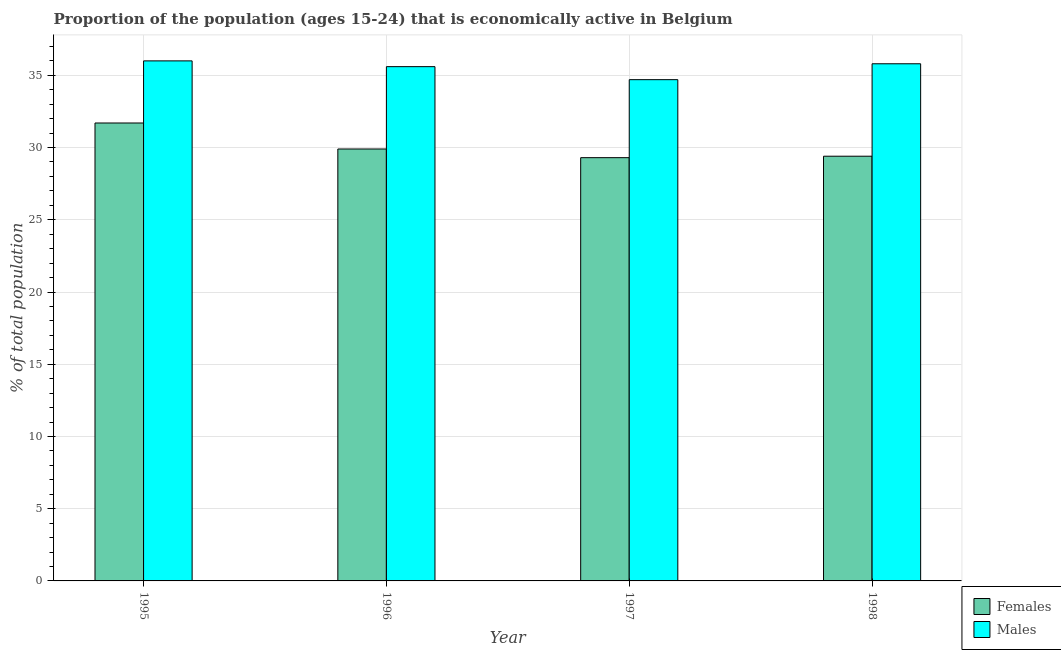How many different coloured bars are there?
Ensure brevity in your answer.  2. How many groups of bars are there?
Your answer should be very brief. 4. Are the number of bars on each tick of the X-axis equal?
Make the answer very short. Yes. How many bars are there on the 4th tick from the left?
Your answer should be very brief. 2. How many bars are there on the 4th tick from the right?
Ensure brevity in your answer.  2. What is the label of the 4th group of bars from the left?
Keep it short and to the point. 1998. What is the percentage of economically active female population in 1995?
Your response must be concise. 31.7. Across all years, what is the maximum percentage of economically active female population?
Provide a succinct answer. 31.7. Across all years, what is the minimum percentage of economically active female population?
Ensure brevity in your answer.  29.3. In which year was the percentage of economically active female population maximum?
Provide a succinct answer. 1995. What is the total percentage of economically active male population in the graph?
Offer a very short reply. 142.1. What is the difference between the percentage of economically active male population in 1995 and that in 1996?
Ensure brevity in your answer.  0.4. What is the difference between the percentage of economically active female population in 1998 and the percentage of economically active male population in 1996?
Give a very brief answer. -0.5. What is the average percentage of economically active male population per year?
Offer a very short reply. 35.52. What is the ratio of the percentage of economically active male population in 1995 to that in 1998?
Your answer should be compact. 1.01. What is the difference between the highest and the second highest percentage of economically active male population?
Keep it short and to the point. 0.2. What is the difference between the highest and the lowest percentage of economically active female population?
Ensure brevity in your answer.  2.4. In how many years, is the percentage of economically active male population greater than the average percentage of economically active male population taken over all years?
Provide a short and direct response. 3. What does the 1st bar from the left in 1998 represents?
Your response must be concise. Females. What does the 1st bar from the right in 1997 represents?
Ensure brevity in your answer.  Males. Are all the bars in the graph horizontal?
Ensure brevity in your answer.  No. How many years are there in the graph?
Your response must be concise. 4. What is the difference between two consecutive major ticks on the Y-axis?
Your answer should be very brief. 5. Are the values on the major ticks of Y-axis written in scientific E-notation?
Give a very brief answer. No. Does the graph contain any zero values?
Make the answer very short. No. Does the graph contain grids?
Your response must be concise. Yes. Where does the legend appear in the graph?
Offer a terse response. Bottom right. How many legend labels are there?
Make the answer very short. 2. What is the title of the graph?
Your response must be concise. Proportion of the population (ages 15-24) that is economically active in Belgium. Does "Registered firms" appear as one of the legend labels in the graph?
Provide a succinct answer. No. What is the label or title of the X-axis?
Your answer should be very brief. Year. What is the label or title of the Y-axis?
Keep it short and to the point. % of total population. What is the % of total population in Females in 1995?
Your answer should be very brief. 31.7. What is the % of total population of Females in 1996?
Give a very brief answer. 29.9. What is the % of total population of Males in 1996?
Your response must be concise. 35.6. What is the % of total population of Females in 1997?
Ensure brevity in your answer.  29.3. What is the % of total population of Males in 1997?
Keep it short and to the point. 34.7. What is the % of total population in Females in 1998?
Provide a short and direct response. 29.4. What is the % of total population of Males in 1998?
Provide a succinct answer. 35.8. Across all years, what is the maximum % of total population in Females?
Offer a terse response. 31.7. Across all years, what is the minimum % of total population in Females?
Your answer should be compact. 29.3. Across all years, what is the minimum % of total population in Males?
Give a very brief answer. 34.7. What is the total % of total population of Females in the graph?
Keep it short and to the point. 120.3. What is the total % of total population in Males in the graph?
Provide a short and direct response. 142.1. What is the difference between the % of total population in Females in 1995 and that in 1997?
Your answer should be very brief. 2.4. What is the difference between the % of total population in Males in 1995 and that in 1998?
Offer a very short reply. 0.2. What is the difference between the % of total population in Females in 1996 and that in 1998?
Give a very brief answer. 0.5. What is the difference between the % of total population in Males in 1996 and that in 1998?
Your response must be concise. -0.2. What is the difference between the % of total population of Males in 1997 and that in 1998?
Your response must be concise. -1.1. What is the difference between the % of total population in Females in 1995 and the % of total population in Males in 1996?
Your response must be concise. -3.9. What is the difference between the % of total population in Females in 1995 and the % of total population in Males in 1998?
Give a very brief answer. -4.1. What is the average % of total population in Females per year?
Ensure brevity in your answer.  30.07. What is the average % of total population of Males per year?
Your answer should be compact. 35.52. In the year 1996, what is the difference between the % of total population of Females and % of total population of Males?
Make the answer very short. -5.7. What is the ratio of the % of total population in Females in 1995 to that in 1996?
Offer a terse response. 1.06. What is the ratio of the % of total population in Males in 1995 to that in 1996?
Ensure brevity in your answer.  1.01. What is the ratio of the % of total population of Females in 1995 to that in 1997?
Offer a terse response. 1.08. What is the ratio of the % of total population in Males in 1995 to that in 1997?
Offer a very short reply. 1.04. What is the ratio of the % of total population of Females in 1995 to that in 1998?
Offer a terse response. 1.08. What is the ratio of the % of total population in Males in 1995 to that in 1998?
Offer a terse response. 1.01. What is the ratio of the % of total population of Females in 1996 to that in 1997?
Provide a short and direct response. 1.02. What is the ratio of the % of total population in Males in 1996 to that in 1997?
Ensure brevity in your answer.  1.03. What is the ratio of the % of total population of Males in 1997 to that in 1998?
Keep it short and to the point. 0.97. What is the difference between the highest and the second highest % of total population of Females?
Your answer should be very brief. 1.8. What is the difference between the highest and the second highest % of total population of Males?
Give a very brief answer. 0.2. What is the difference between the highest and the lowest % of total population of Females?
Make the answer very short. 2.4. What is the difference between the highest and the lowest % of total population of Males?
Your answer should be very brief. 1.3. 